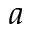<formula> <loc_0><loc_0><loc_500><loc_500>a</formula> 